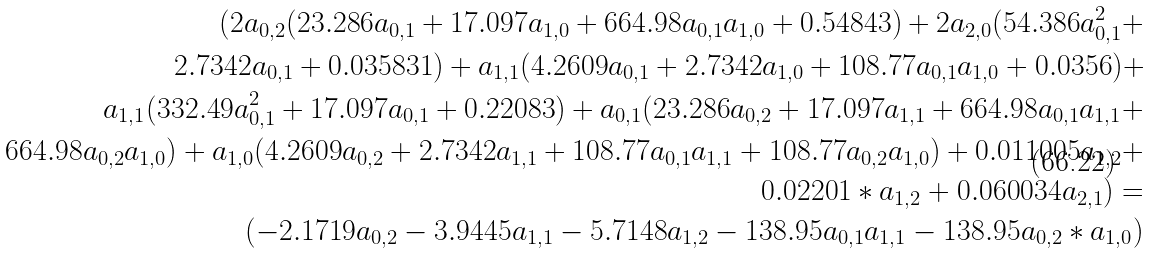<formula> <loc_0><loc_0><loc_500><loc_500>( 2 a _ { 0 , 2 } ( 2 3 . 2 8 6 a _ { 0 , 1 } + 1 7 . 0 9 7 a _ { 1 , 0 } + 6 6 4 . 9 8 a _ { 0 , 1 } a _ { 1 , 0 } + 0 . 5 4 8 4 3 ) + 2 a _ { 2 , 0 } ( 5 4 . 3 8 6 a _ { 0 , 1 } ^ { 2 } + \\ 2 . 7 3 4 2 a _ { 0 , 1 } + 0 . 0 3 5 8 3 1 ) + a _ { 1 , 1 } ( 4 . 2 6 0 9 a _ { 0 , 1 } + 2 . 7 3 4 2 a _ { 1 , 0 } + 1 0 8 . 7 7 a _ { 0 , 1 } a _ { 1 , 0 } + 0 . 0 3 5 6 ) + \\ a _ { 1 , 1 } ( 3 3 2 . 4 9 a _ { 0 , 1 } ^ { 2 } + 1 7 . 0 9 7 a _ { 0 , 1 } + 0 . 2 2 0 8 3 ) + a _ { 0 , 1 } ( 2 3 . 2 8 6 a _ { 0 , 2 } + 1 7 . 0 9 7 a _ { 1 , 1 } + 6 6 4 . 9 8 a _ { 0 , 1 } a _ { 1 , 1 } + \\ 6 6 4 . 9 8 a _ { 0 , 2 } a _ { 1 , 0 } ) + a _ { 1 , 0 } ( 4 . 2 6 0 9 a _ { 0 , 2 } + 2 . 7 3 4 2 a _ { 1 , 1 } + 1 0 8 . 7 7 a _ { 0 , 1 } a _ { 1 , 1 } + 1 0 8 . 7 7 a _ { 0 , 2 } a _ { 1 , 0 } ) + 0 . 0 1 1 0 0 5 a _ { 1 , 2 } + \\ 0 . 0 2 2 0 1 * a _ { 1 , 2 } + 0 . 0 6 0 0 3 4 a _ { 2 , 1 } ) = \\ ( - 2 . 1 7 1 9 a _ { 0 , 2 } - 3 . 9 4 4 5 a _ { 1 , 1 } - 5 . 7 1 4 8 a _ { 1 , 2 } - 1 3 8 . 9 5 a _ { 0 , 1 } a _ { 1 , 1 } - 1 3 8 . 9 5 a _ { 0 , 2 } * a _ { 1 , 0 } )</formula> 